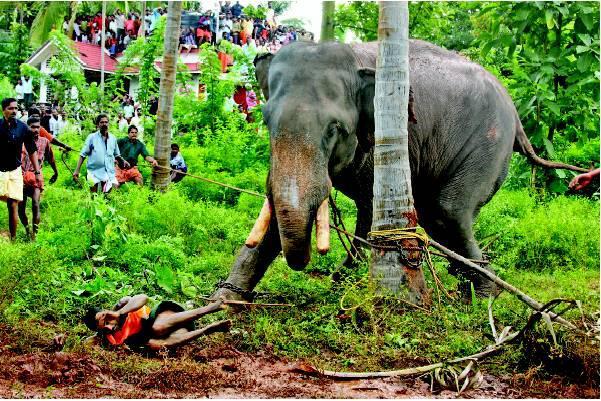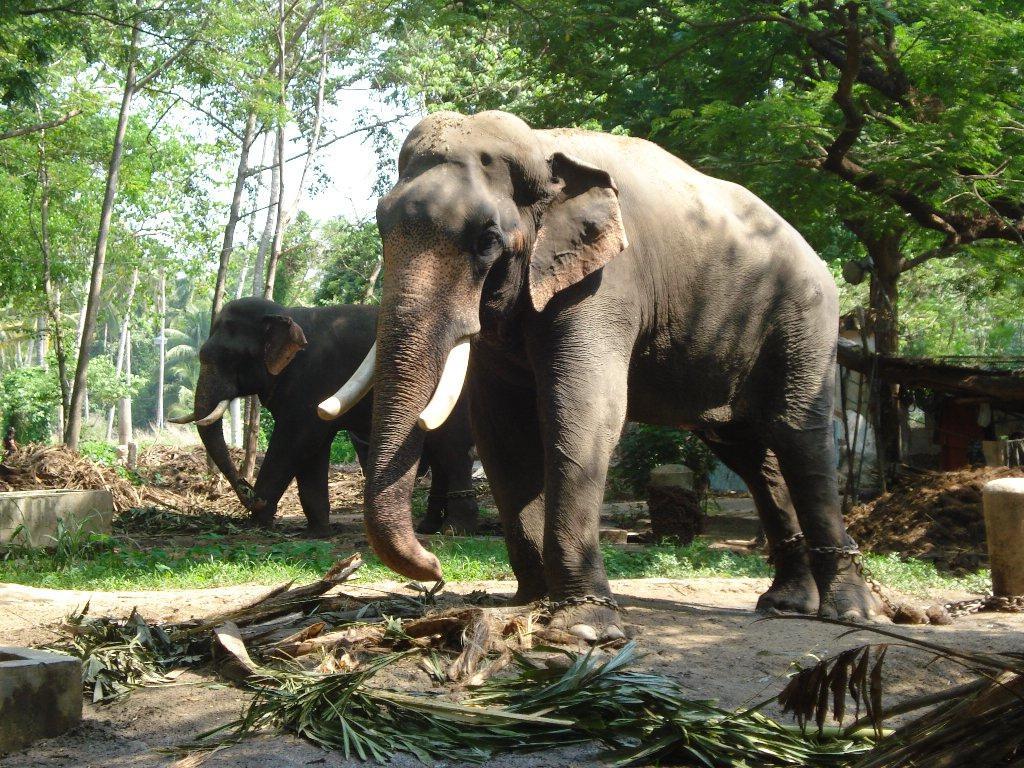The first image is the image on the left, the second image is the image on the right. Given the left and right images, does the statement "At least one image shows people near an elephant with chained feet." hold true? Answer yes or no. Yes. The first image is the image on the left, the second image is the image on the right. Considering the images on both sides, is "At least one of the images shows people interacting with an elephant." valid? Answer yes or no. Yes. 